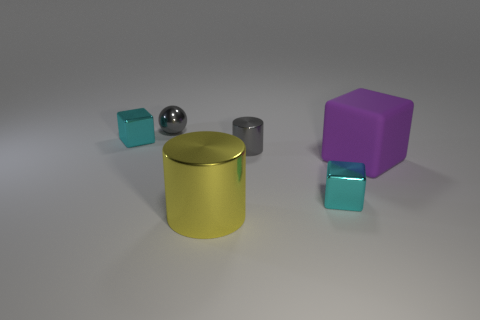How do the colors of the objects contribute to the overall aesthetic of the scene? The colors offer a pleasant contrast, with the vivid purple and cyan adding a pop of color against the more muted gray and gold tones, creating a visually balanced and interesting scene. 